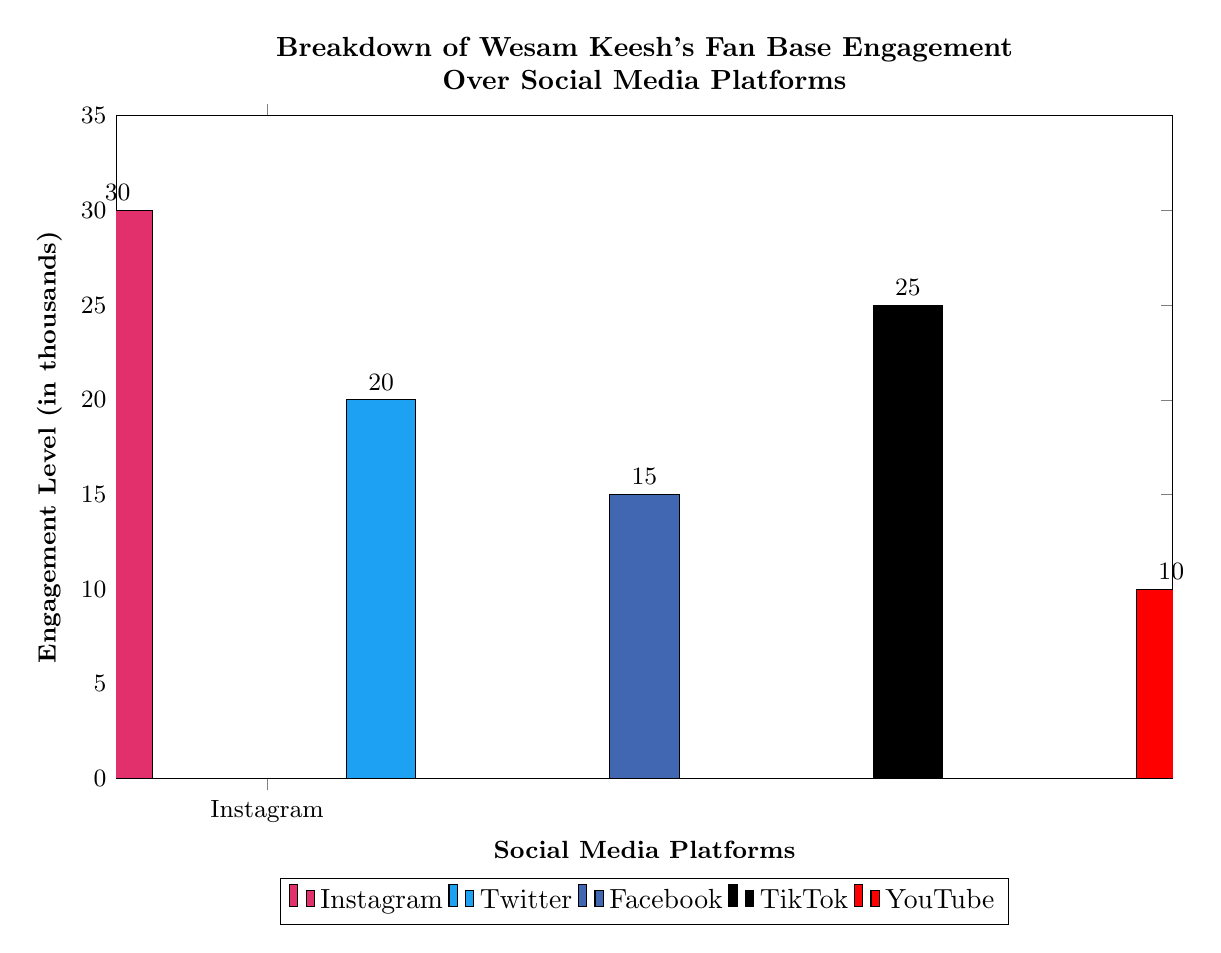What is the engagement level on Instagram? The histogram shows that the bar for Instagram reaches up to 30 on the vertical engagement level axis, indicating the number of thousands of interactions.
Answer: 30 Which platform has the lowest engagement level? By examining the height of each bar, YouTube has the lowest engagement level, represented by the bar sitting at 10 on the vertical axis.
Answer: YouTube What is the difference in engagement levels between Twitter and TikTok? The Twitter bar measures 20 and the TikTok bar measures 25. The difference can be calculated as 25 minus 20, resulting in a difference of 5.
Answer: 5 Which two platforms have engagement levels that are closest to each other? Comparing the specific heights, Facebook has an engagement level of 15 and YouTube has 10; however, TikTok (25) and Twitter (20) are only 5 units apart, making them the closest pair of platforms in terms of engagement.
Answer: TikTok and Twitter What percentage of the total engagement is attributed to Instagram? First, calculate the total engagement: 30 (Instagram) + 20 (Twitter) + 15 (Facebook) + 25 (TikTok) + 10 (YouTube) = 100. Then, find the percentage by dividing Instagram's engagement (30) by the total (100), which gives 30%.
Answer: 30% How much higher is TikTok's engagement than Facebook's? TikTok's engagement level is 25, and Facebook's is 15. The difference is found by subtracting 15 from 25, resulting in 10.
Answer: 10 What is the total engagement level across all platforms? Adding the engagement levels together: 30 (Instagram) + 20 (Twitter) + 15 (Facebook) + 25 (TikTok) + 10 (YouTube) gives a total of 100.
Answer: 100 Which platform ranks second in engagement level? By assessing the heights, Instagram is the highest at 30, followed by TikTok at 25, hence TikTok is the platform that ranks second.
Answer: TikTok 